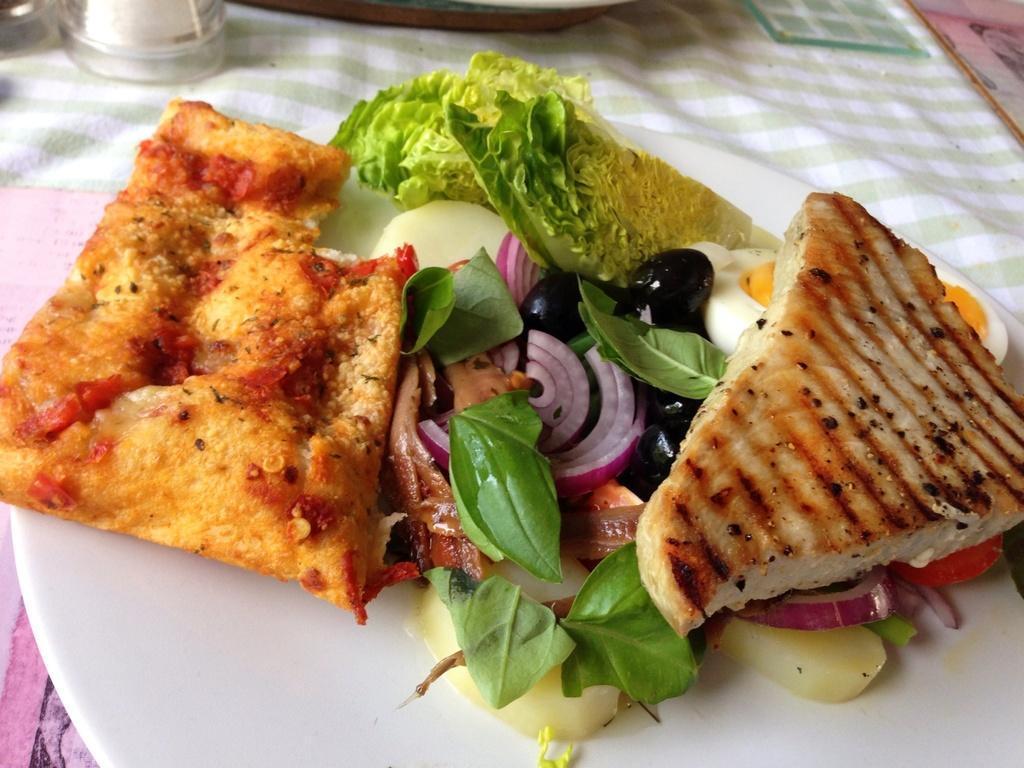Describe this image in one or two sentences. In this image, we can see food on the plate and in the background, there is a glass and we can see an object. At the bottom, there is cloth on the table. 